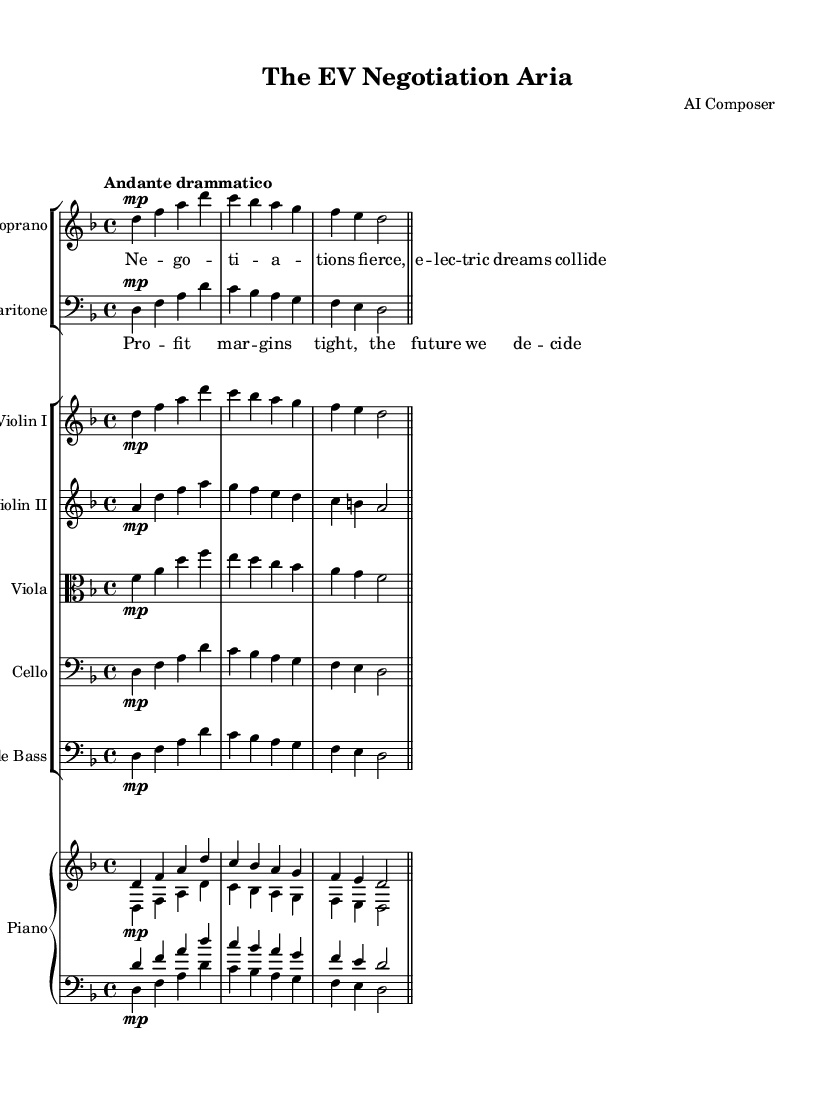What is the key signature of this music? The key signature is indicated at the beginning of the staff. It shows one flat, indicating that the key is D minor.
Answer: D minor What is the time signature of this music? The time signature is shown at the beginning of the piece, where it reads as a fractional number. It indicates that there are 4 beats per measure.
Answer: 4/4 What is the tempo marking for this piece? The tempo marking appears at the start and specifies the character of the music. Here, it indicates the music should be played in a slow and dramatic manner.
Answer: Andante drammatico How many instruments are featured in this score? By counting the distinct staves labeled with instrument names, we find there are six types of instruments included: Soprano, Baritone, Violin I, Violin II, Viola, Cello, Double Bass, and Piano.
Answer: Seven Which vocal parts are included in this opera? The vocal parts are specified within the music sheet under the appropriate labels, distinguishing between higher and lower ranges. The score distinctly includes Soprano and Baritone.
Answer: Soprano and Baritone What thematic concept does the lyrics focus on? Analyzing the provided lyrics, we can see a focus on negotiations, economic aspects, and future decisions within the electrical vehicle sector context.
Answer: Negotiations and future decisions What structure is common in opera reflected in this piece? In opera, the use of two distinct vocal parts, typically representing characters in dialogue or conflict, reflects a narrative and dramatic structure, as seen with the Soprano and Baritone interplay.
Answer: Duet structure 